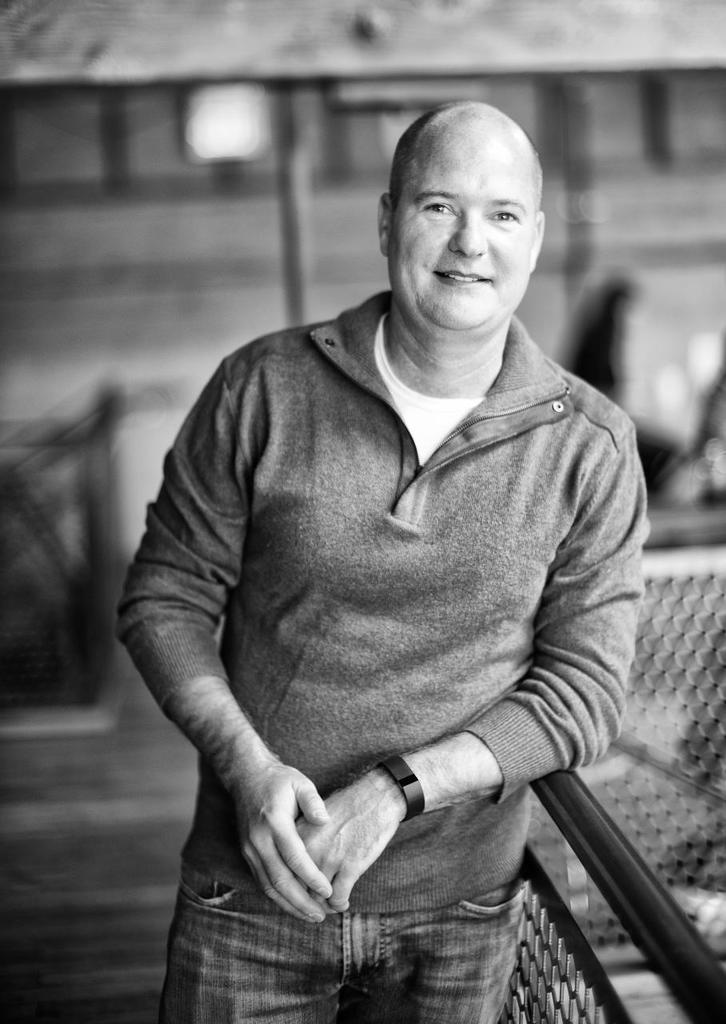Who is present in the image? There is a man in the image. What is located at the bottom of the image? There is a road at the bottom of the image. What can be seen on the right side of the image? There is a fencing on the right side of the image. What is visible in the background of the image? There is a building in the background of the image. What type of shop does the man own, and what is the date on the calendar in the image? There is no shop or calendar present in the image. 